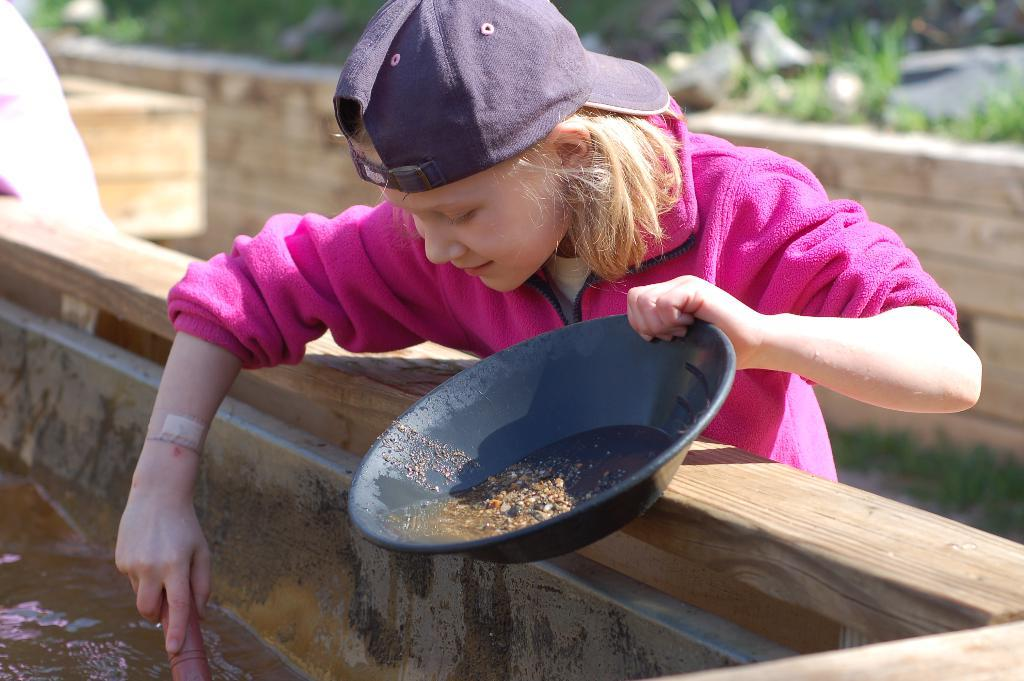Who is the main subject in the image? There is a girl in the image. What is the girl doing in the image? The girl is standing in the image. What is the girl holding in the image? The girl is holding a bowl in the image. What is inside the bowl that the girl is holding? There is water in the bowl that the girl is holding. How would you describe the background of the image? The background of the image is blurry. What type of disease can be seen on the girl's face in the image? There is no disease visible on the girl's face in the image. What company is responsible for the hydrant in the image? There is no hydrant present in the image. 